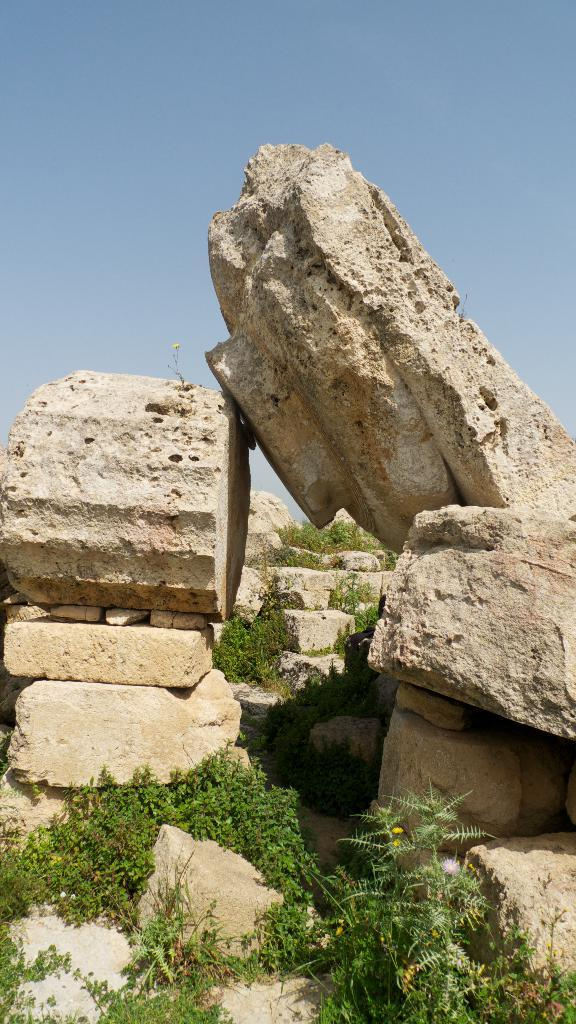What type of living organisms can be seen in the image? Plants can be seen in the image. What color are the plants in the image? The plants are green in color. What other objects are present in the image besides plants? Rocks are present in the image. What color are the rocks in the image? The rocks are cream in color. What can be seen in the background of the image? The sky is visible in the background of the image. What type of bag can be seen in the image? There is no bag present in the image. How does the plant stretch towards the sky in the image? Plants do not stretch towards the sky in the image; they are stationary and do not move. 